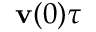Convert formula to latex. <formula><loc_0><loc_0><loc_500><loc_500>v ( 0 ) \tau</formula> 